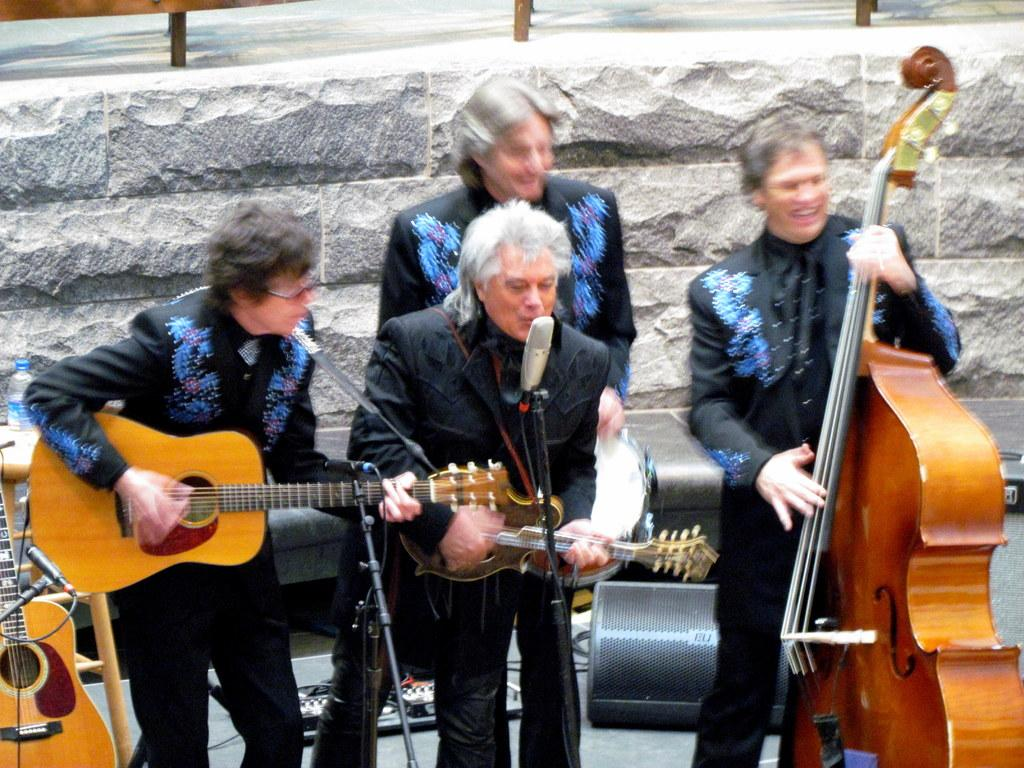What activity are the people in the image engaged in? The group of people in the image are sitting on the beach. What can be seen in the background of the image? There are waves in the background of the image. What type of jelly can be seen floating in the water near the group of people? There is no jelly visible in the image; it features a group of people sitting on the beach with waves in the background. 